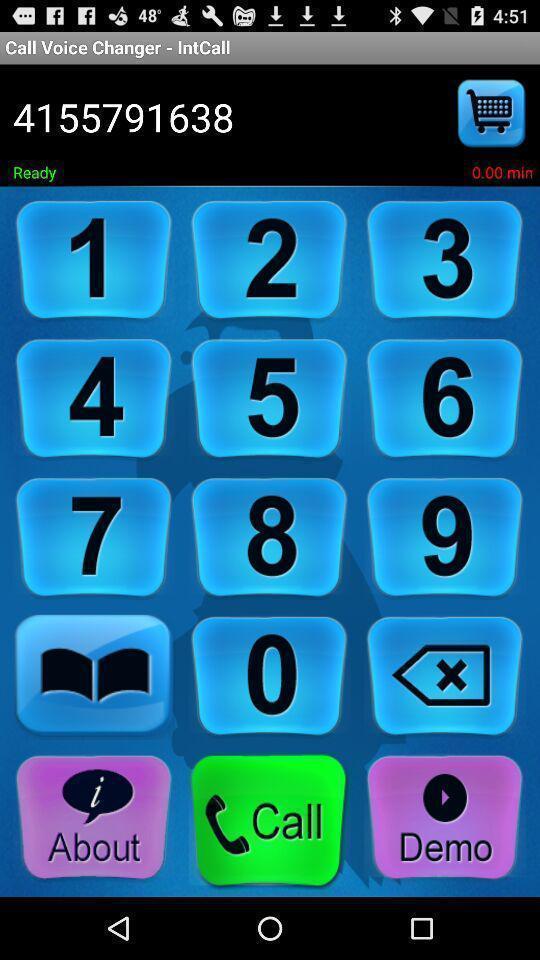Describe the visual elements of this screenshot. Page shows the call options of call voice changer. 